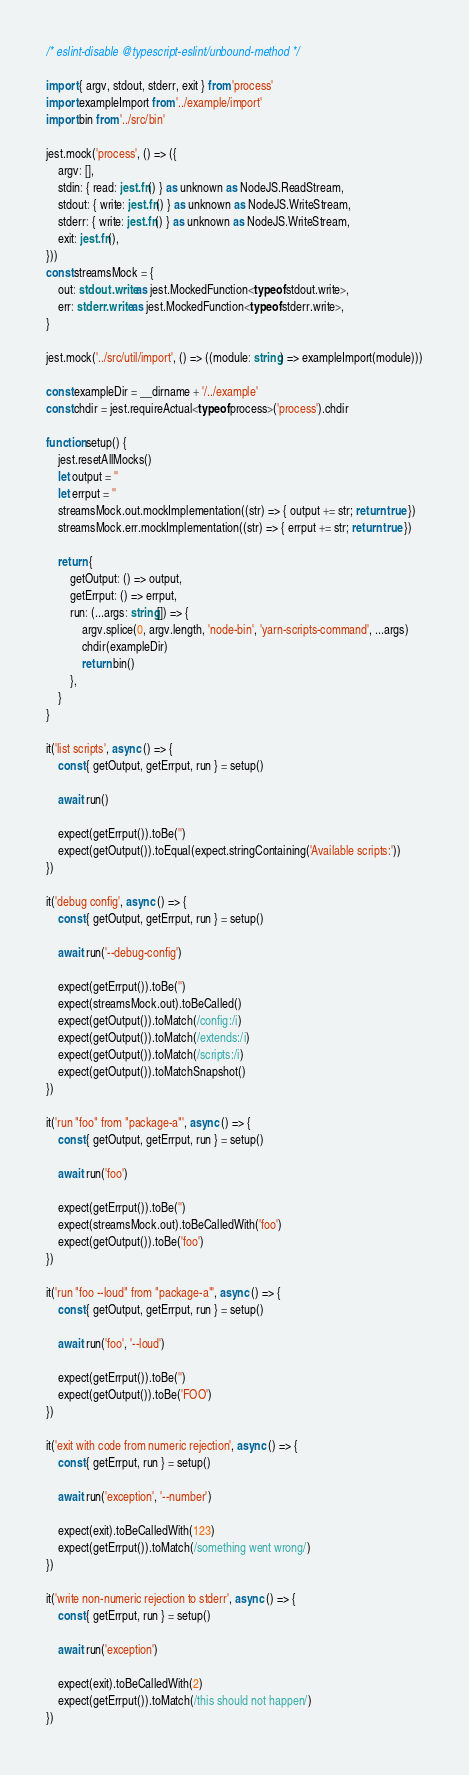Convert code to text. <code><loc_0><loc_0><loc_500><loc_500><_TypeScript_>/* eslint-disable @typescript-eslint/unbound-method */

import { argv, stdout, stderr, exit } from 'process'
import exampleImport from '../example/import'
import bin from '../src/bin'

jest.mock('process', () => ({
    argv: [],
    stdin: { read: jest.fn() } as unknown as NodeJS.ReadStream,
    stdout: { write: jest.fn() } as unknown as NodeJS.WriteStream,
    stderr: { write: jest.fn() } as unknown as NodeJS.WriteStream,
    exit: jest.fn(),
}))
const streamsMock = {
    out: stdout.write as jest.MockedFunction<typeof stdout.write>,
    err: stderr.write as jest.MockedFunction<typeof stderr.write>,
}

jest.mock('../src/util/import', () => ((module: string) => exampleImport(module)))

const exampleDir = __dirname + '/../example'
const chdir = jest.requireActual<typeof process>('process').chdir

function setup() {
    jest.resetAllMocks()
    let output = ''
    let errput = ''
    streamsMock.out.mockImplementation((str) => { output += str; return true })
    streamsMock.err.mockImplementation((str) => { errput += str; return true })

    return {
        getOutput: () => output,
        getErrput: () => errput,
        run: (...args: string[]) => {
            argv.splice(0, argv.length, 'node-bin', 'yarn-scripts-command', ...args)
            chdir(exampleDir)
            return bin()
        },
    }
}

it('list scripts', async () => {
    const { getOutput, getErrput, run } = setup()

    await run()

    expect(getErrput()).toBe('')
    expect(getOutput()).toEqual(expect.stringContaining('Available scripts:'))
})

it('debug config', async () => {
    const { getOutput, getErrput, run } = setup()

    await run('--debug-config')

    expect(getErrput()).toBe('')
    expect(streamsMock.out).toBeCalled()
    expect(getOutput()).toMatch(/config:/i)
    expect(getOutput()).toMatch(/extends:/i)
    expect(getOutput()).toMatch(/scripts:/i)
    expect(getOutput()).toMatchSnapshot()
})

it('run "foo" from "package-a"', async () => {
    const { getOutput, getErrput, run } = setup()

    await run('foo')

    expect(getErrput()).toBe('')
    expect(streamsMock.out).toBeCalledWith('foo')
    expect(getOutput()).toBe('foo')
})

it('run "foo --loud" from "package-a"', async () => {
    const { getOutput, getErrput, run } = setup()

    await run('foo', '--loud')

    expect(getErrput()).toBe('')
    expect(getOutput()).toBe('FOO')
})

it('exit with code from numeric rejection', async () => {
    const { getErrput, run } = setup()

    await run('exception', '--number')

    expect(exit).toBeCalledWith(123)
    expect(getErrput()).toMatch(/something went wrong/)
})

it('write non-numeric rejection to stderr', async () => {
    const { getErrput, run } = setup()

    await run('exception')

    expect(exit).toBeCalledWith(2)
    expect(getErrput()).toMatch(/this should not happen/)
})
</code> 